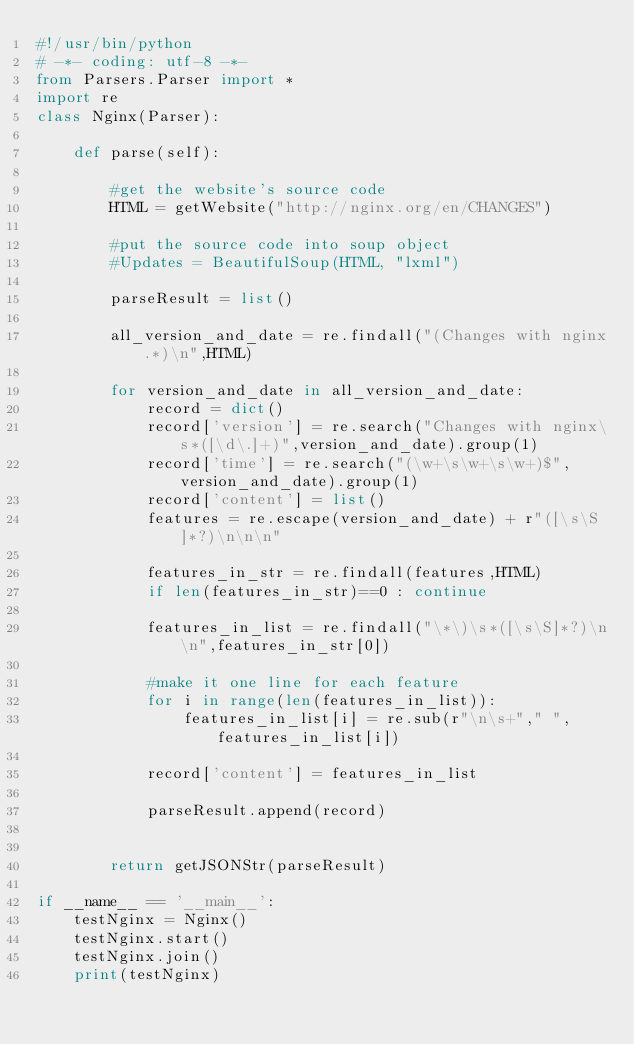<code> <loc_0><loc_0><loc_500><loc_500><_Python_>#!/usr/bin/python
# -*- coding: utf-8 -*-
from Parsers.Parser import *
import re
class Nginx(Parser):

    def parse(self):

        #get the website's source code
        HTML = getWebsite("http://nginx.org/en/CHANGES")

        #put the source code into soup object
        #Updates = BeautifulSoup(HTML, "lxml")

        parseResult = list()

        all_version_and_date = re.findall("(Changes with nginx.*)\n",HTML)

        for version_and_date in all_version_and_date:
            record = dict()
            record['version'] = re.search("Changes with nginx\s*([\d\.]+)",version_and_date).group(1)
            record['time'] = re.search("(\w+\s\w+\s\w+)$",version_and_date).group(1)
            record['content'] = list()
            features = re.escape(version_and_date) + r"([\s\S]*?)\n\n\n"

            features_in_str = re.findall(features,HTML)
            if len(features_in_str)==0 : continue

            features_in_list = re.findall("\*\)\s*([\s\S]*?)\n\n",features_in_str[0])

            #make it one line for each feature
            for i in range(len(features_in_list)):
                features_in_list[i] = re.sub(r"\n\s+"," ",features_in_list[i])

            record['content'] = features_in_list

            parseResult.append(record)
        

        return getJSONStr(parseResult)

if __name__ == '__main__':
    testNginx = Nginx()
    testNginx.start()
    testNginx.join()
    print(testNginx)</code> 